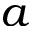Convert formula to latex. <formula><loc_0><loc_0><loc_500><loc_500>a</formula> 